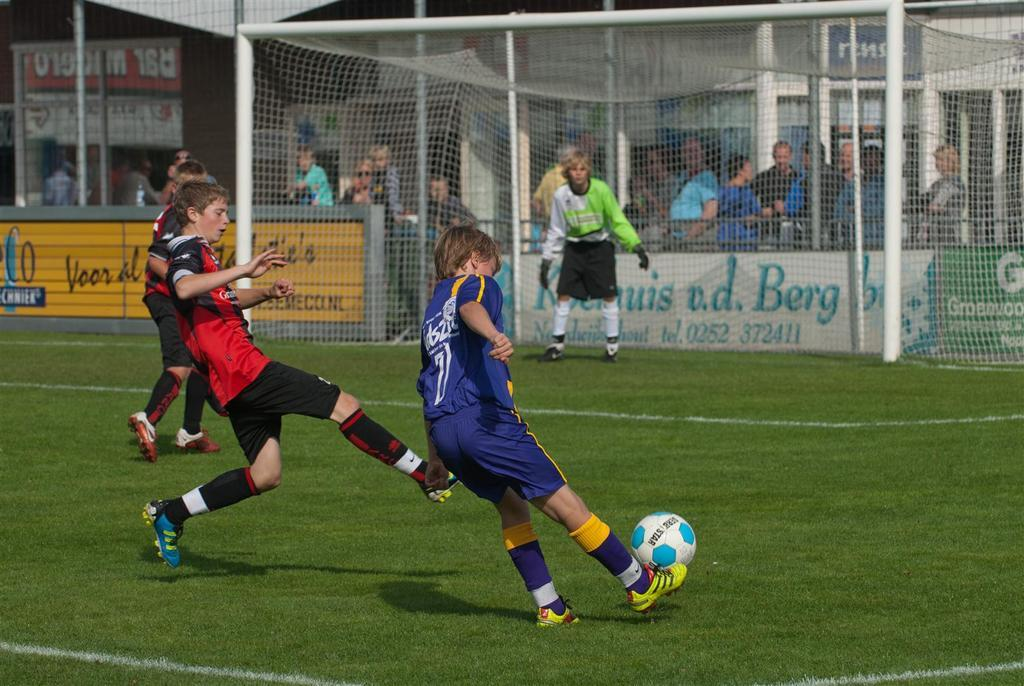<image>
Summarize the visual content of the image. Boys are playing soccer in front of an ad that has the name Berg on it. 